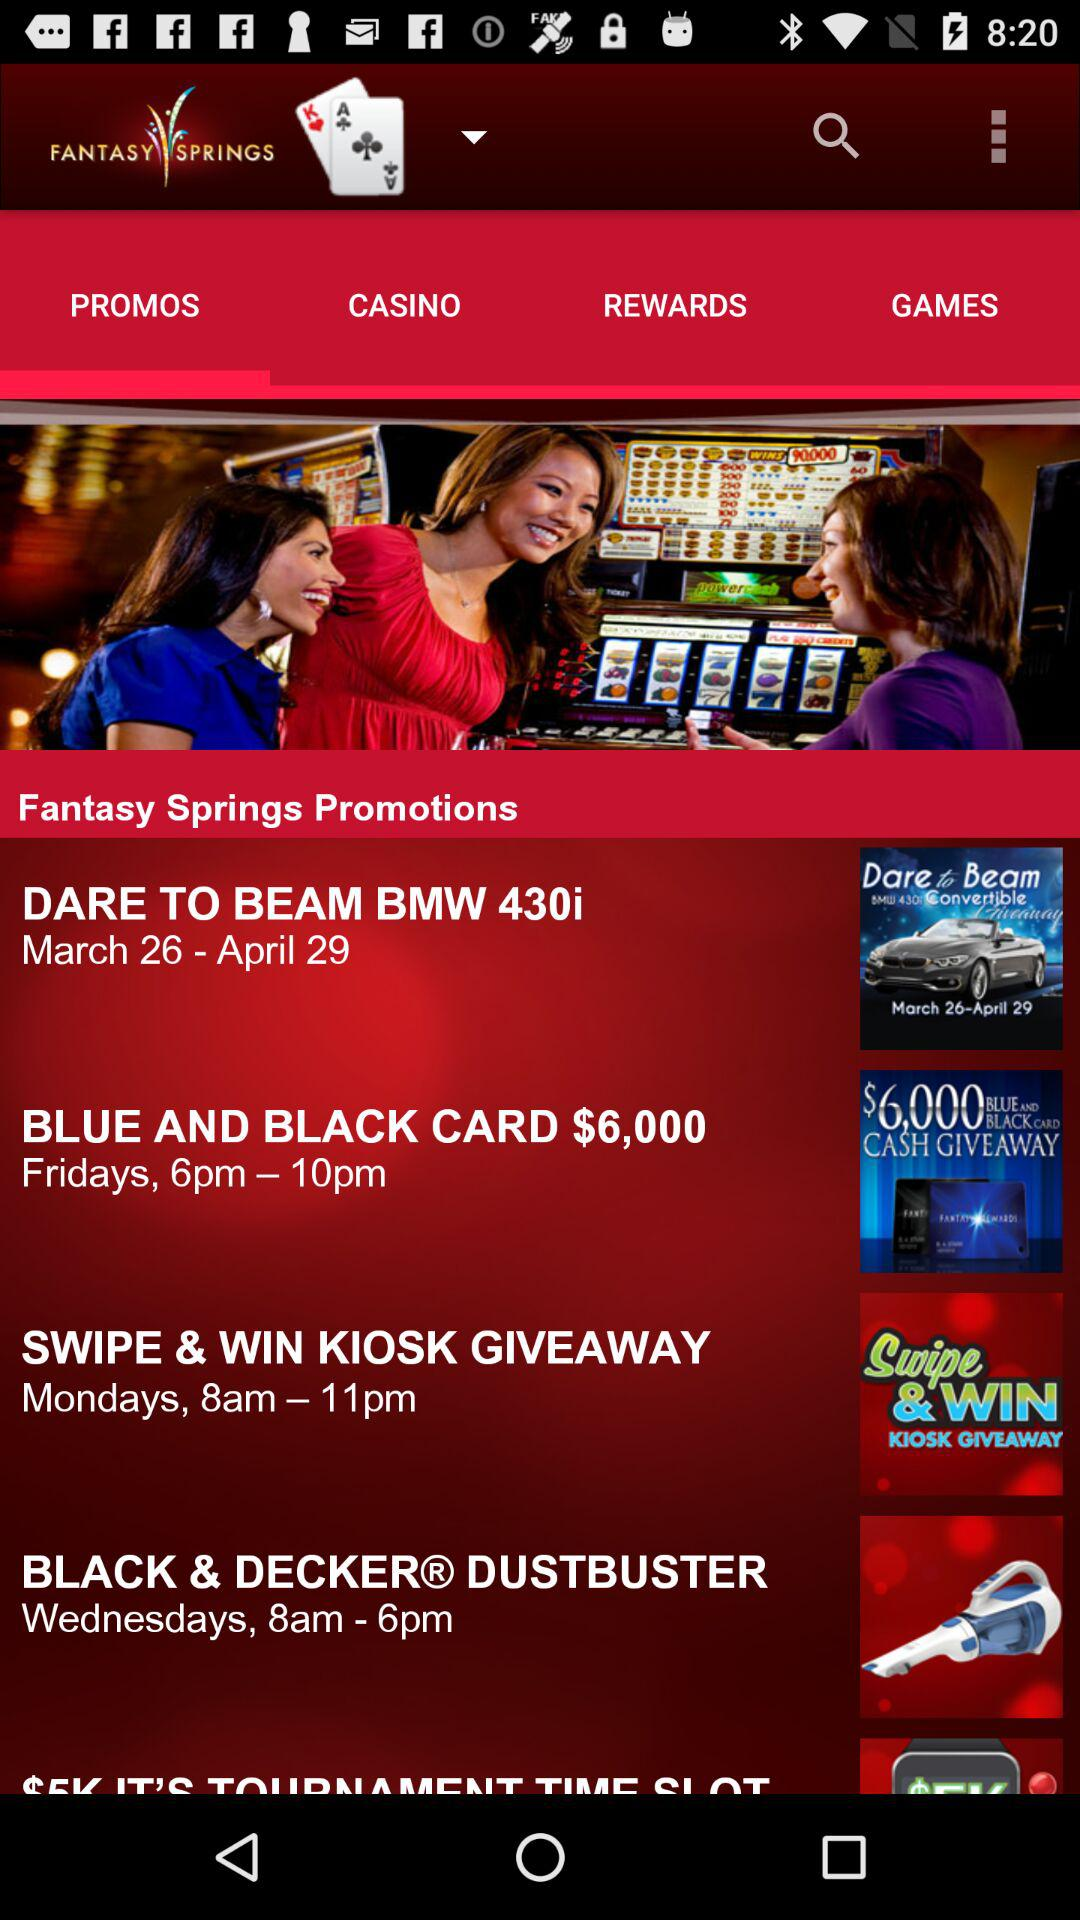Which tab am I on? You are on the "PROMOS" tab. 